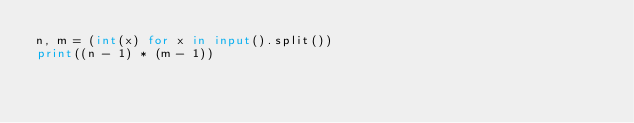Convert code to text. <code><loc_0><loc_0><loc_500><loc_500><_Python_>n, m = (int(x) for x in input().split())
print((n - 1) * (m - 1))
</code> 